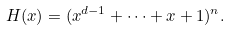<formula> <loc_0><loc_0><loc_500><loc_500>H ( x ) = ( x ^ { d - 1 } + \dots + x + 1 ) ^ { n } .</formula> 